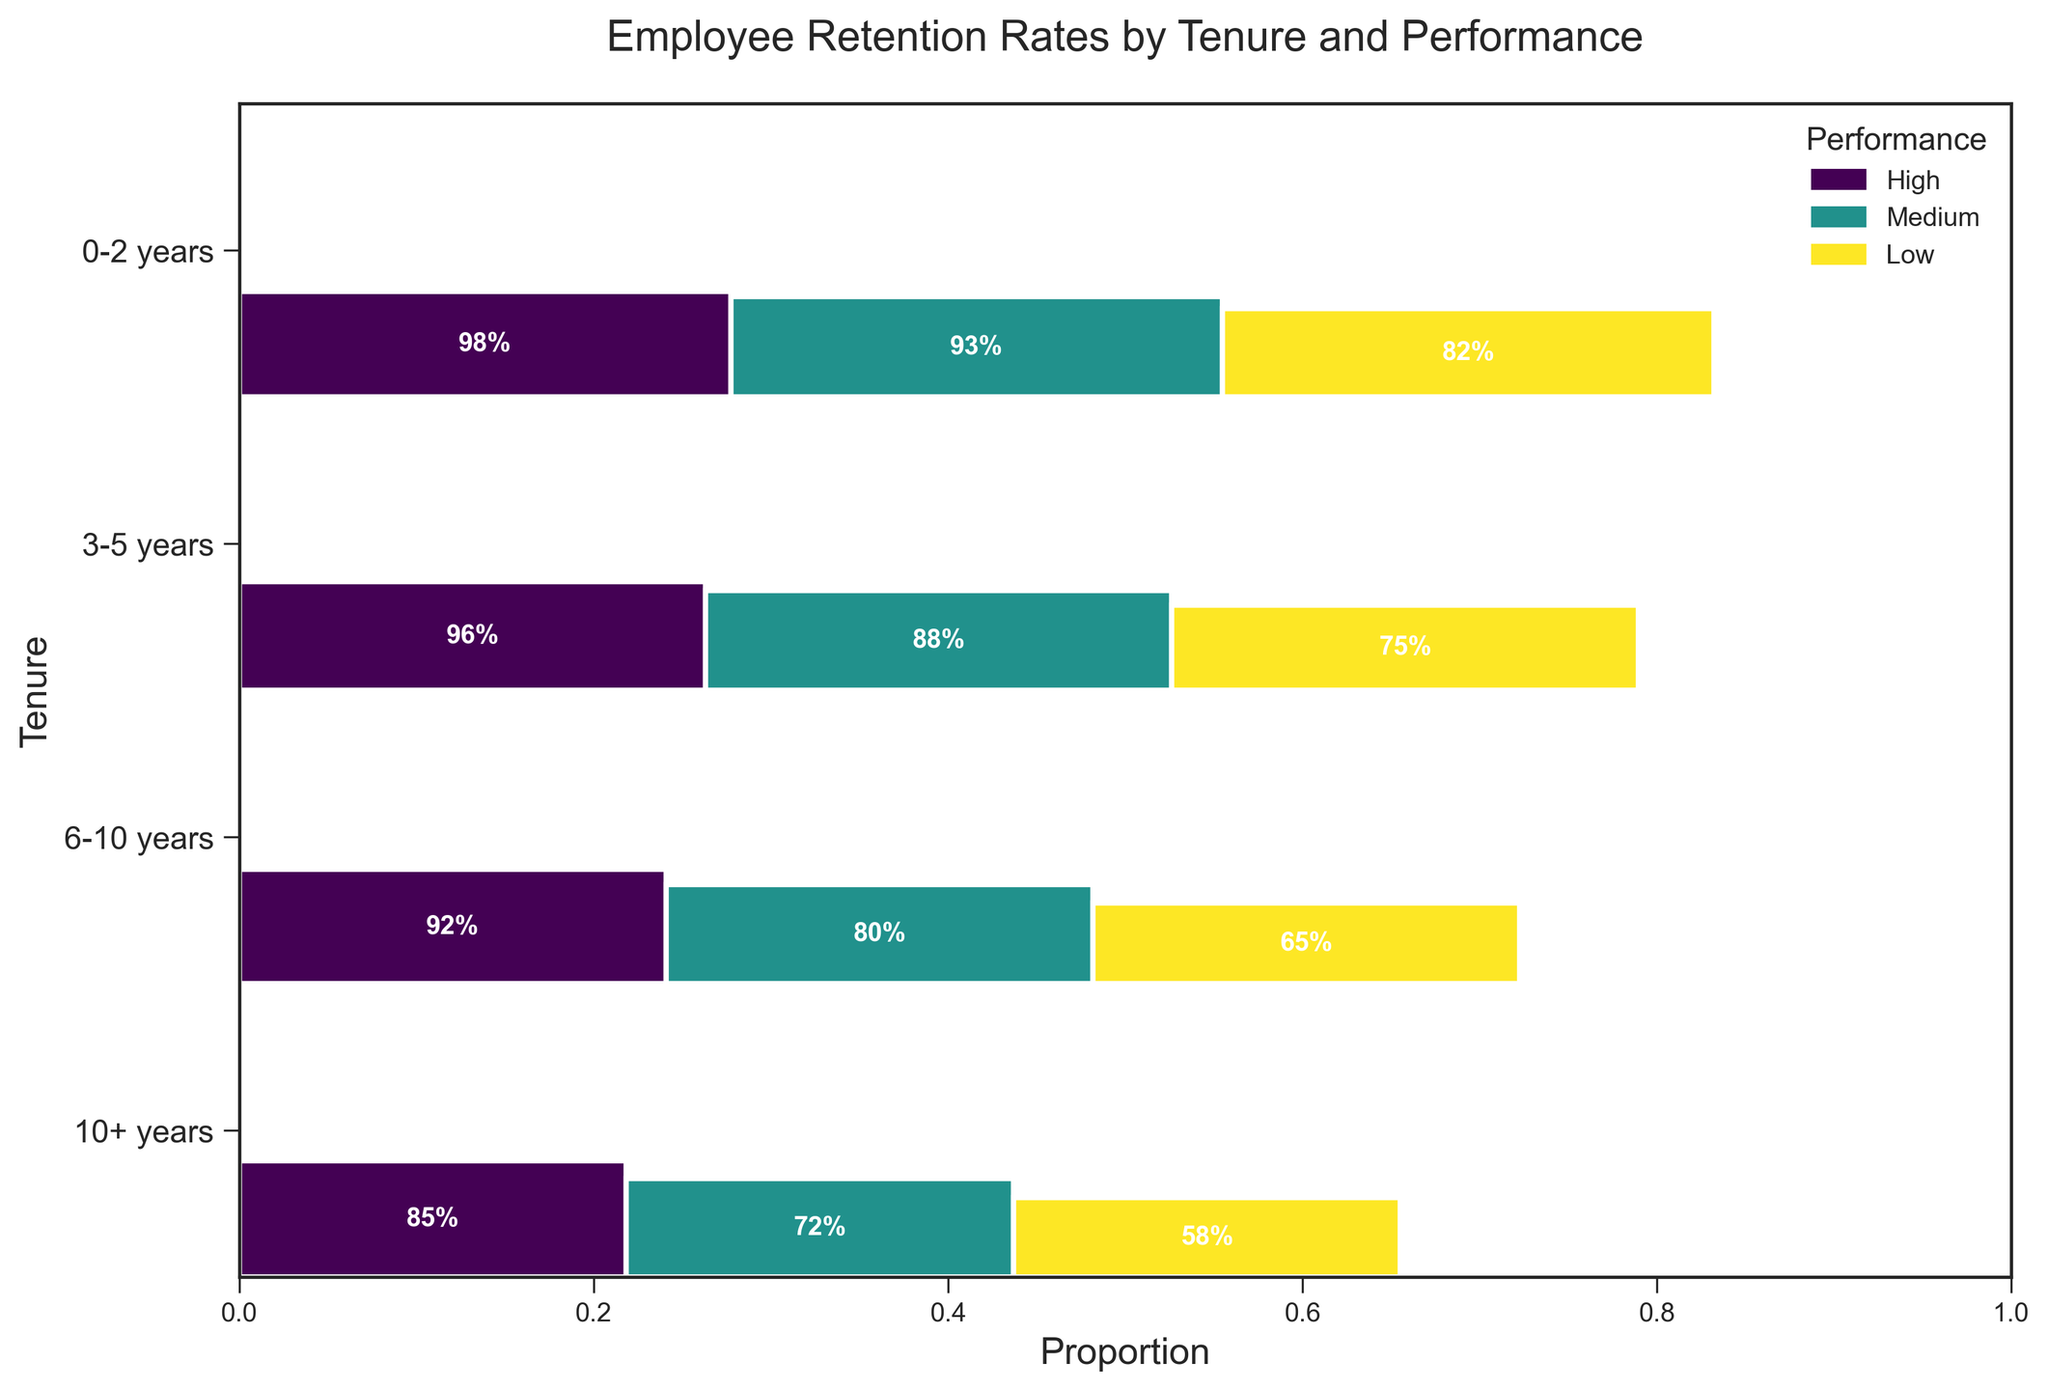What is the overall retention rate for employees with high performance who have worked for 10+ years? Locate the rectangle corresponding to the '10+ years' tenure and 'High' performance level. The retention rate is displayed in the center of this rectangle.
Answer: 98% Which performance level has the highest retention rate for employees with 0-2 years tenure? Compare the retention rates in the rectangles for '0-2 years' tenure among 'High', 'Medium', and 'Low' performance levels. The highest retention rate is displayed in the 'High' performance level rectangle.
Answer: High What is the difference in retention rates between high and low performance levels for employees with 3-5 years tenure? Note the retention rates for 'High' and 'Low' performance levels for '3-5 years' tenure, which are 92% and 65% respectively. Subtract the lower rate from the higher rate: 92% - 65%.
Answer: 27% How does the overall retention rate for employees with 6-10 years tenure compare to those with 0-2 years tenure? The overall retention rate can be observed by comparing the width of the rectangles for '6-10 years' and '0-2 years', since wider sections represent higher overall retention.
Answer: 6-10 years tenure has higher retention Which tenure group has the largest variance in retention rates across different performance levels? Identify the tenure group with the largest difference between its highest and lowest retention rates by visually comparing the height spans of the rectangles within each tenure group. The '0-2 years' tenure group has the widest variance from 58% to 85%, a 27% difference.
Answer: 0-2 years How many performance levels are there in the plot? Count the distinct colors representing different performance levels in the plot legend or among rectangles.
Answer: 3 For which tenure group is the retention rate for medium performance closest to the retention rate for high performance? Compare the retention rates for 'High' and 'Medium' performance levels within each tenure group and find the smallest difference. For '10+ years', the rates are 98% and 93% respectively, which is the smallest difference 5%.
Answer: 10+ years What is the relative proportion of the retention rate for low performance within the 6-10 years tenure group? Find the height of the rectangle representing 'Low' performance in the '6-10 years' tenure group and its relative height visually compared to others in the same tenure group. It appears roughly 30%, since the rates are 96% (High), 88% (Medium), and 75% (Low).
Answer: 30% 